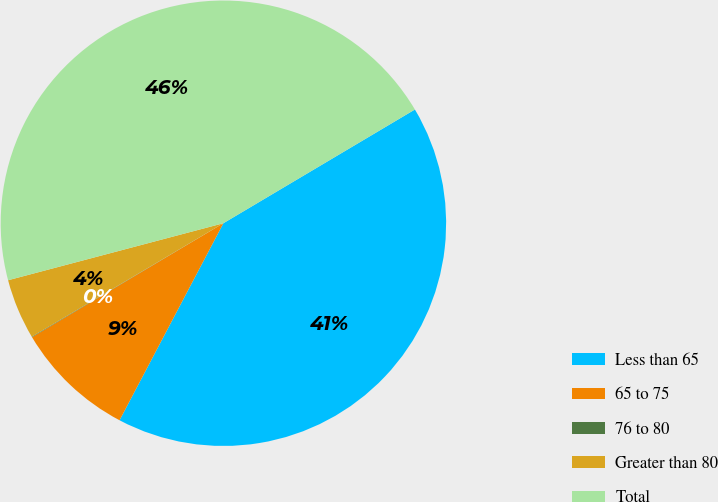Convert chart. <chart><loc_0><loc_0><loc_500><loc_500><pie_chart><fcel>Less than 65<fcel>65 to 75<fcel>76 to 80<fcel>Greater than 80<fcel>Total<nl><fcel>41.25%<fcel>8.73%<fcel>0.04%<fcel>4.39%<fcel>45.59%<nl></chart> 